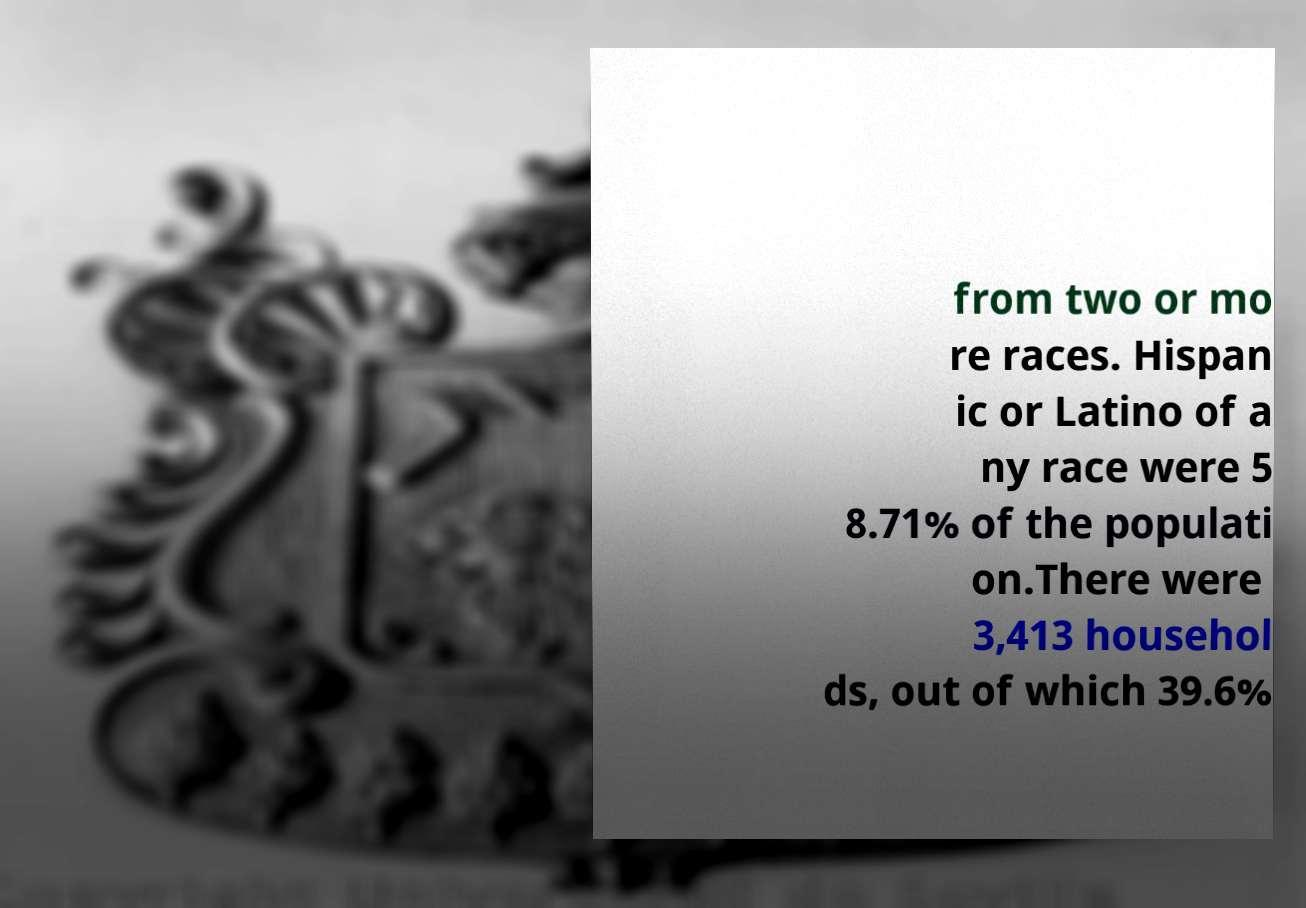Could you extract and type out the text from this image? from two or mo re races. Hispan ic or Latino of a ny race were 5 8.71% of the populati on.There were 3,413 househol ds, out of which 39.6% 